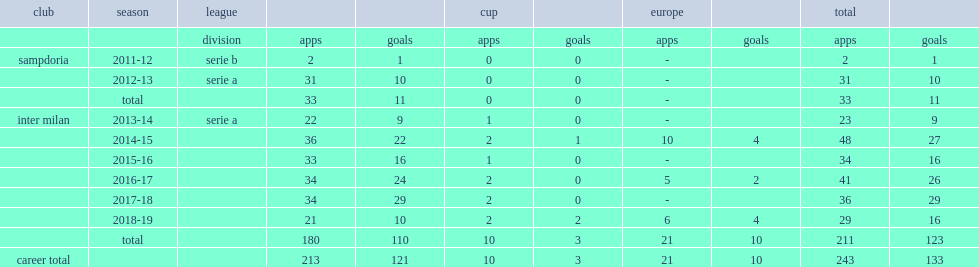How many goals did mauro icardi make for inter in total? 123.0. 